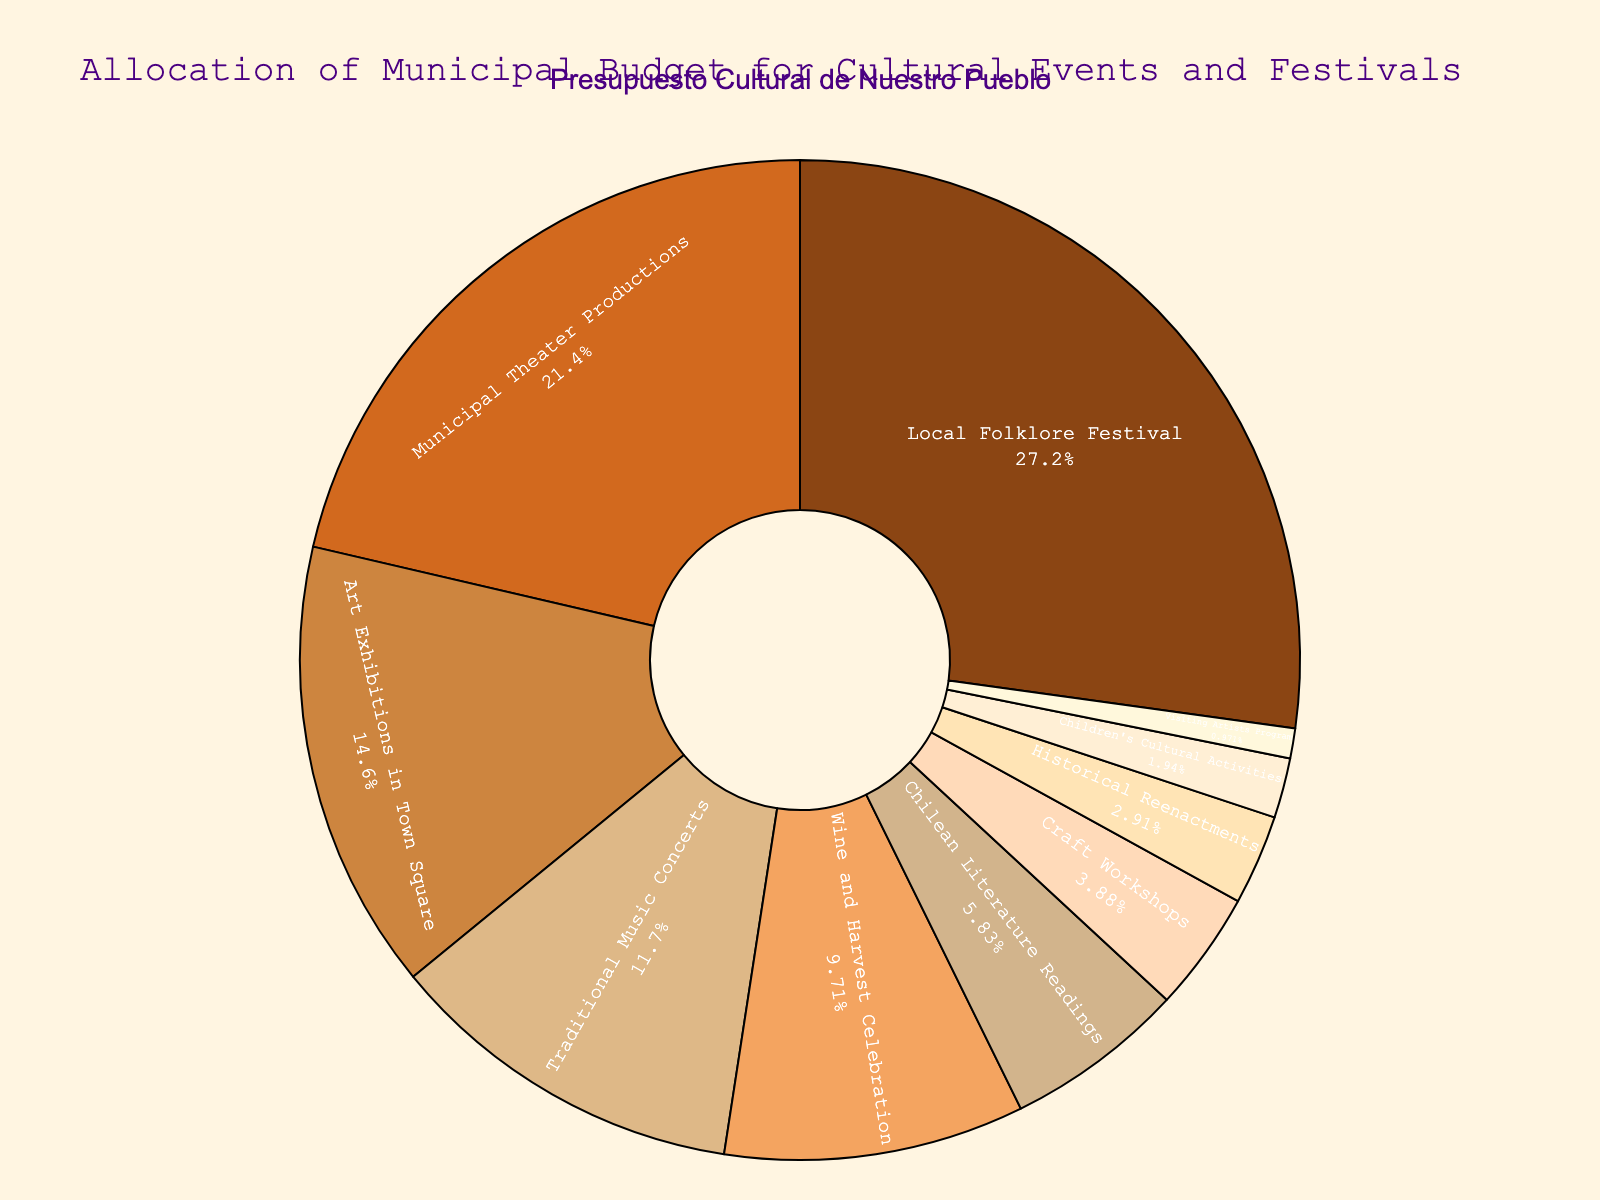Which category receives the highest budget allocation? The chart visually shows each category's budget proportion. The Local Folklore Festival has the largest slice.
Answer: Local Folklore Festival What is the total budget allocation percentage for Art Exhibitions in Town Square and Traditional Music Concerts combined? Art Exhibitions in Town Square get 15%, and Traditional Music Concerts receive 12%. Adding them together: 15% + 12% = 27%.
Answer: 27% How much larger is the allocation for Municipal Theater Productions compared to Wine and Harvest Celebration? Municipal Theater Productions have 22%, and Wine and Harvest Celebration has 10%. The difference is 22% - 10% = 12%.
Answer: 12% Which category has the smallest budget allocation? By looking at the smallest slice on the pie chart, the Visiting Artists Program receives the smallest percentage.
Answer: Visiting Artists Program What is the combined budget allocation for categories with less than 5%? The categories with less than 5% are Craft Workshops (4%), Historical Reenactments (3%), Children's Cultural Activities (2%), and Visiting Artists Program (1%). Summing these percentages: 4% + 3% + 2% + 1% = 10%.
Answer: 10% What is the approximate visual proportion of the category allocated to Children's Cultural Activities on the chart? The Children's Cultural Activities section is quite small, about 2% of the entire circle, visually confirming the label.
Answer: 2% How does the budget for Chilean Literature Readings compare to Craft Workshops? Chilean Literature Readings receive 6% while Craft Workshops receive 4%. Comparing these: 6% is greater than 4%.
Answer: Greater than Among the top three budgeted categories, what is the total budget percentage? The top three categories are Local Folklore Festival (28%), Municipal Theater Productions (22%), and Art Exhibitions in Town Square (15%). Adding these: 28% + 22% + 15% = 65%.
Answer: 65% What percentage of the budget is allocated to events with a music component? The events including a music component are Traditional Music Concerts (12%) and Local Folklore Festival (28%), totaling 12% + 28% = 40%.
Answer: 40% How does the budget for Wine and Harvest Celebration compare visually to that of Municipal Theater Productions? Wine and Harvest Celebration's slice is noticeably smaller than that of Municipal Theater Productions, indicating a smaller budget allocation.
Answer: Smaller 